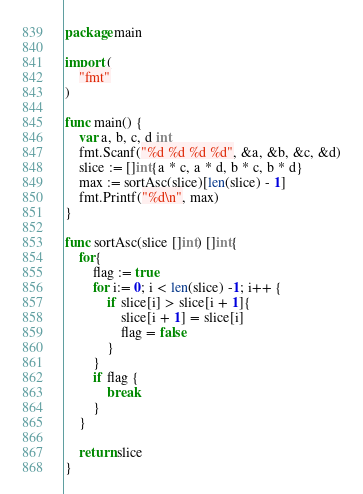Convert code to text. <code><loc_0><loc_0><loc_500><loc_500><_Go_>package main
 
import (
	"fmt"
)
 
func main() {
	var a, b, c, d int
	fmt.Scanf("%d %d %d %d", &a, &b, &c, &d)
	slice := []int{a * c, a * d, b * c, b * d}
	max := sortAsc(slice)[len(slice) - 1]
	fmt.Printf("%d\n", max)
}

func sortAsc(slice []int) []int{
	for{
		flag := true
		for i:= 0; i < len(slice) -1; i++ {
			if slice[i] > slice[i + 1]{
				slice[i + 1] = slice[i]
				flag = false
			}
		}
		if flag {
			break
		}
	} 

	return slice
} </code> 